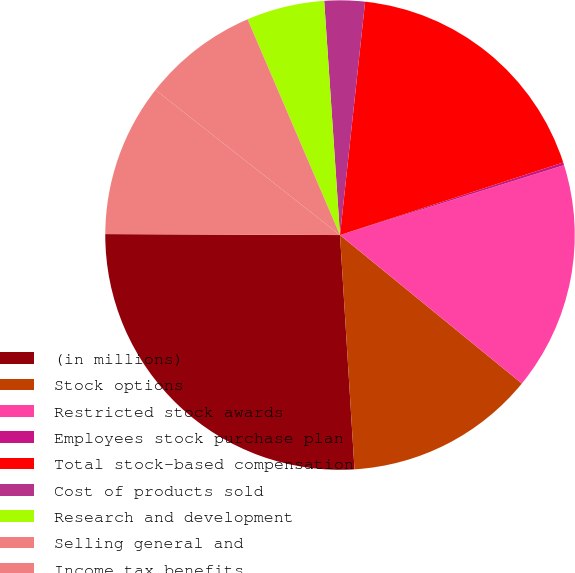Convert chart to OTSL. <chart><loc_0><loc_0><loc_500><loc_500><pie_chart><fcel>(in millions)<fcel>Stock options<fcel>Restricted stock awards<fcel>Employees stock purchase plan<fcel>Total stock-based compensation<fcel>Cost of products sold<fcel>Research and development<fcel>Selling general and<fcel>Income tax benefits<nl><fcel>26.05%<fcel>13.12%<fcel>15.71%<fcel>0.19%<fcel>18.29%<fcel>2.78%<fcel>5.37%<fcel>7.95%<fcel>10.54%<nl></chart> 